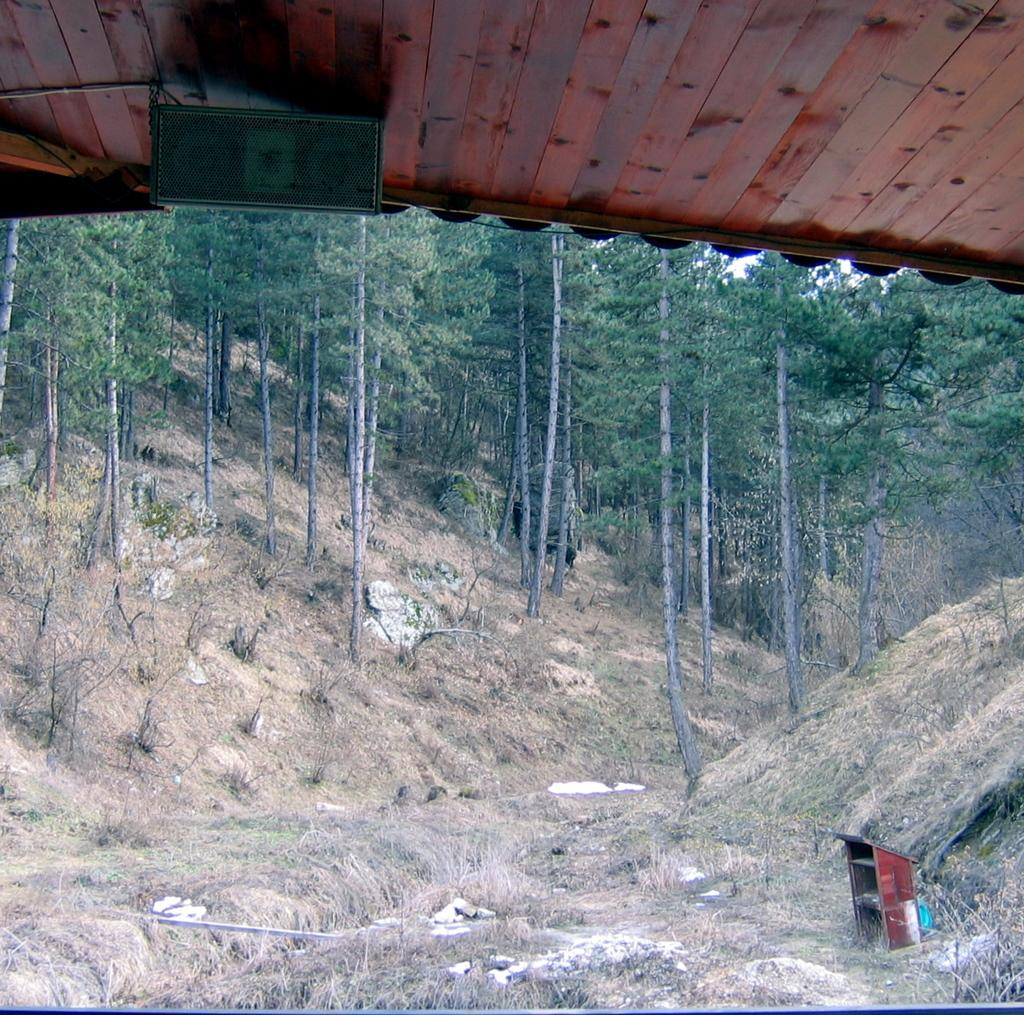What type of terrain is visible at the top of the image? There is ground with dry grass and small rocks at the top of the image. What can be seen behind the ground? There are trees behind the ground. What structure is located at the top of the image? There is a wooden roof at the top of the image. What object is on the wooden roof? There is a black color machine on the wooden roof. Who is the expert in stitching the need in the image? There is no expert or stitching activity present in the image. 